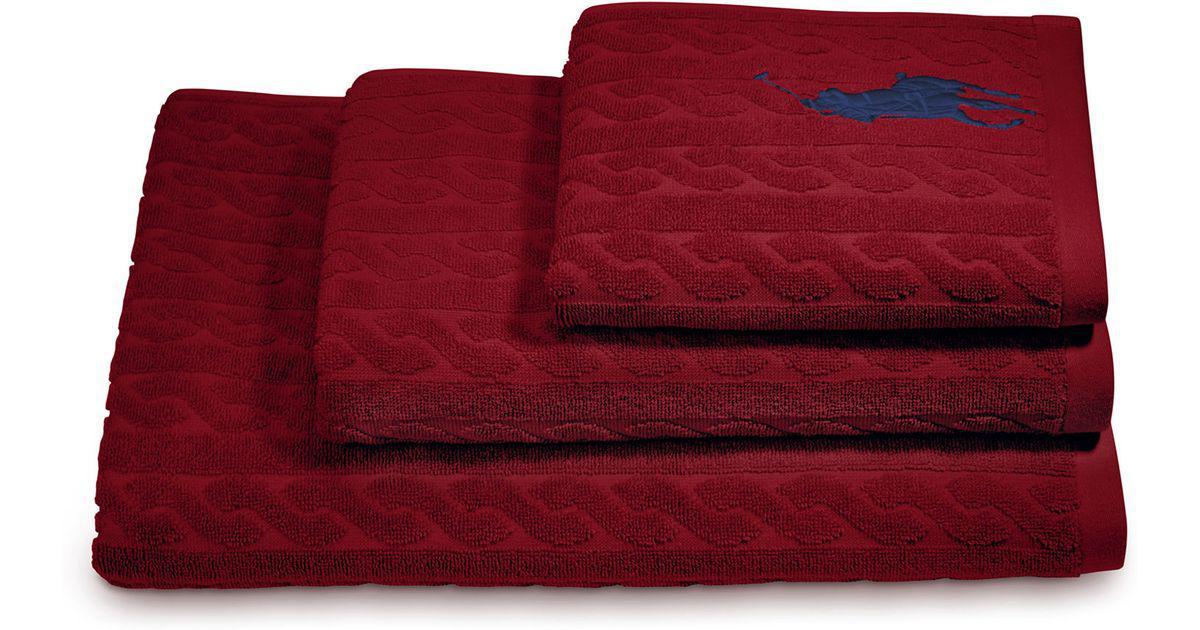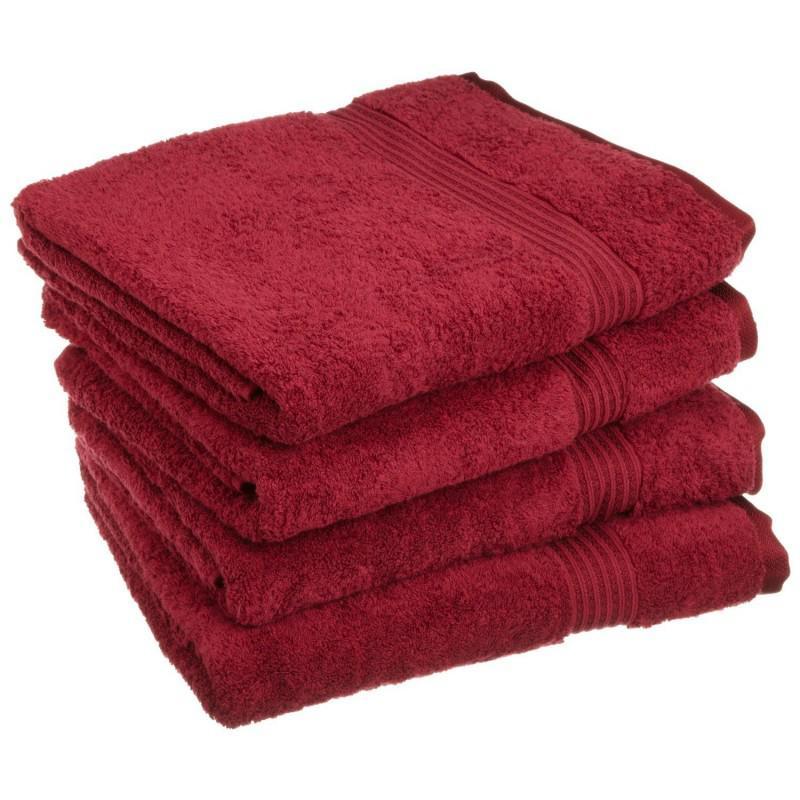The first image is the image on the left, the second image is the image on the right. Examine the images to the left and right. Is the description "Seven or fewer towels are visible." accurate? Answer yes or no. Yes. The first image is the image on the left, the second image is the image on the right. For the images shown, is this caption "IN at least one image there is a tower of three red towels." true? Answer yes or no. Yes. 